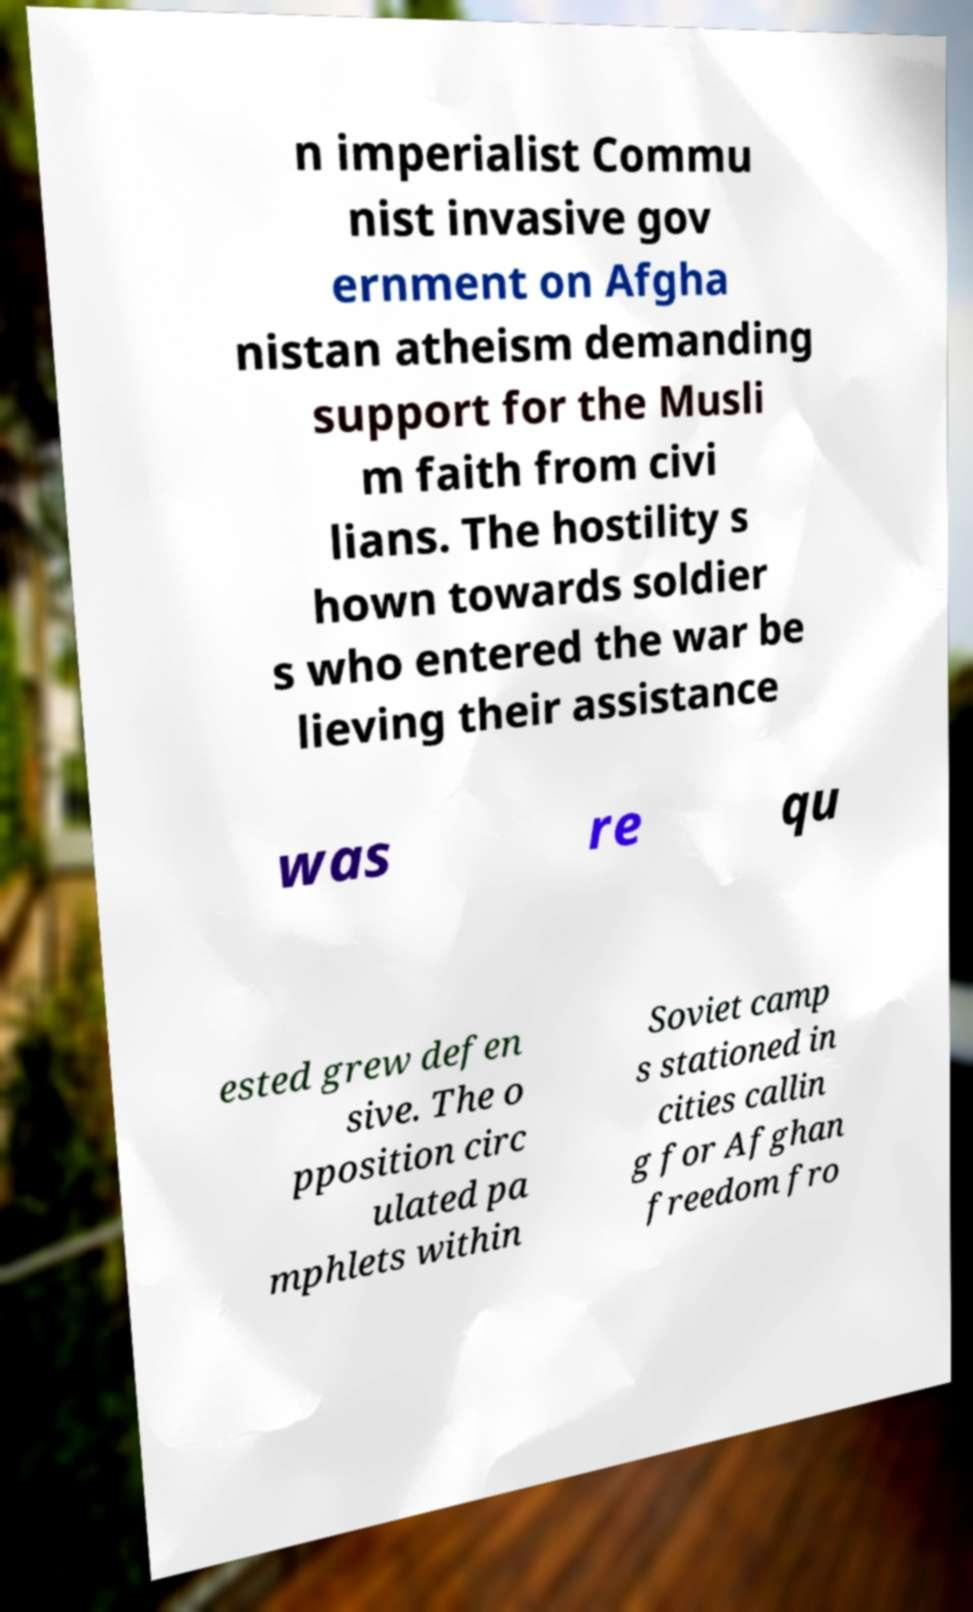Could you assist in decoding the text presented in this image and type it out clearly? n imperialist Commu nist invasive gov ernment on Afgha nistan atheism demanding support for the Musli m faith from civi lians. The hostility s hown towards soldier s who entered the war be lieving their assistance was re qu ested grew defen sive. The o pposition circ ulated pa mphlets within Soviet camp s stationed in cities callin g for Afghan freedom fro 